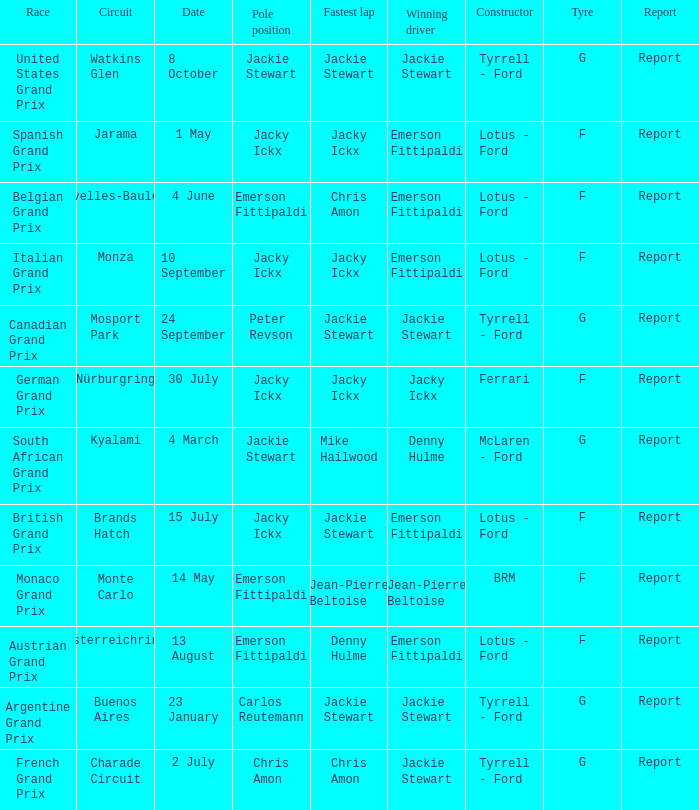When did the Argentine Grand Prix race? 23 January. 